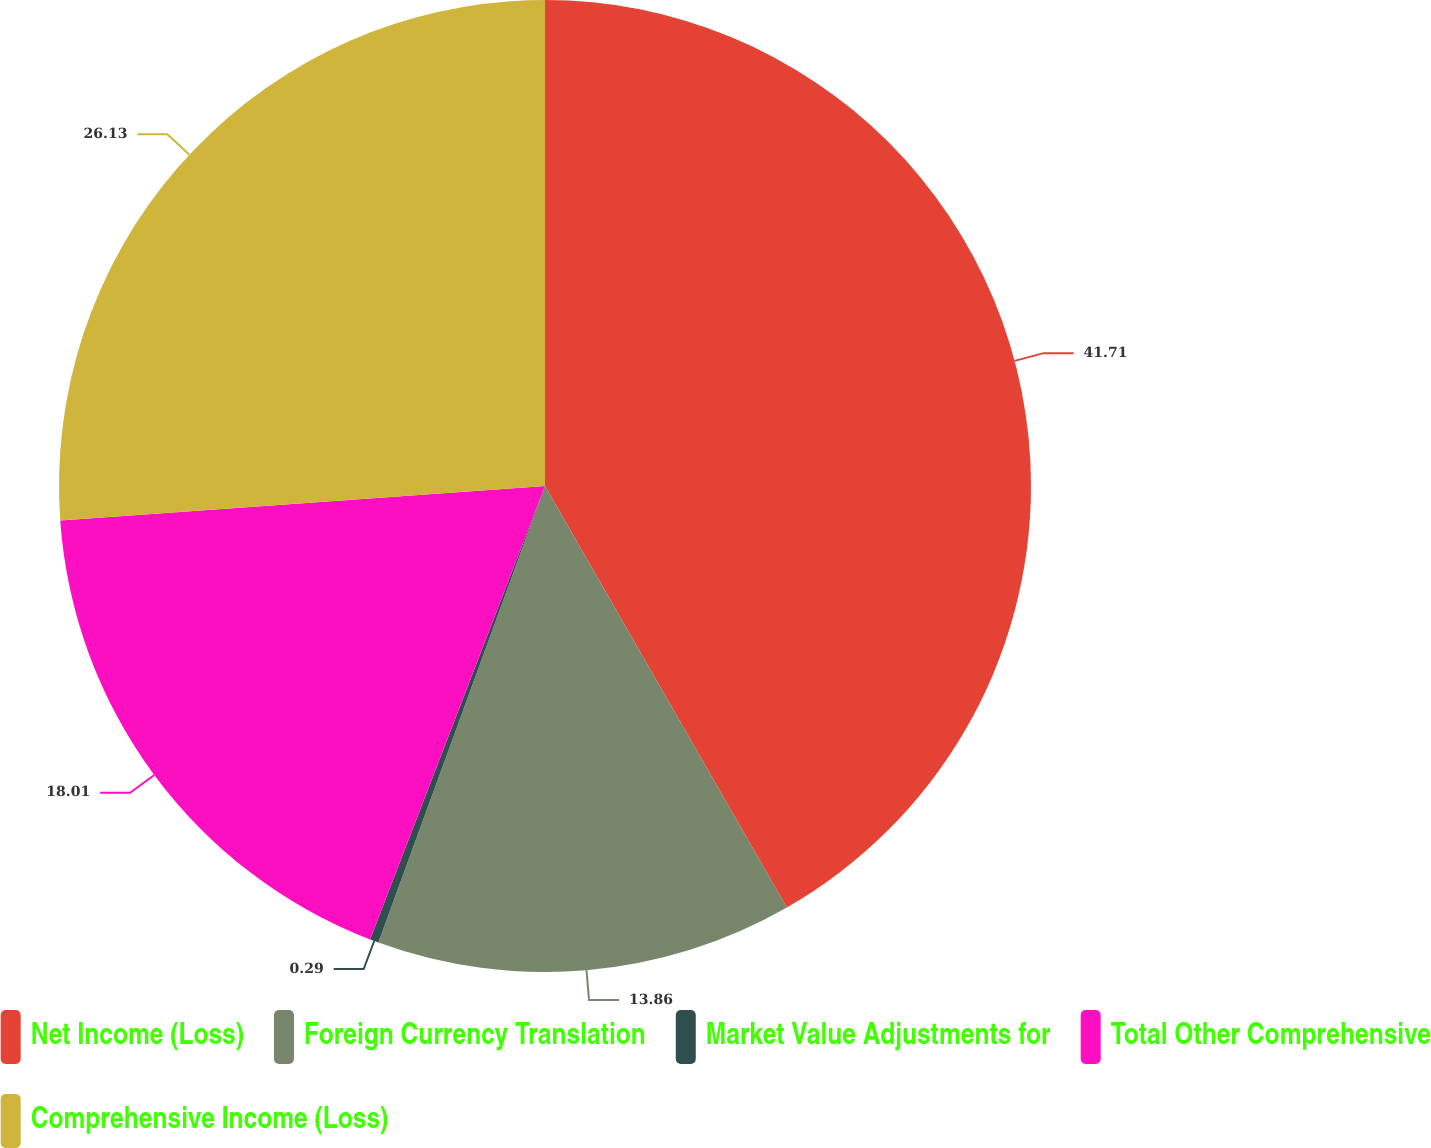Convert chart to OTSL. <chart><loc_0><loc_0><loc_500><loc_500><pie_chart><fcel>Net Income (Loss)<fcel>Foreign Currency Translation<fcel>Market Value Adjustments for<fcel>Total Other Comprehensive<fcel>Comprehensive Income (Loss)<nl><fcel>41.71%<fcel>13.86%<fcel>0.29%<fcel>18.01%<fcel>26.13%<nl></chart> 